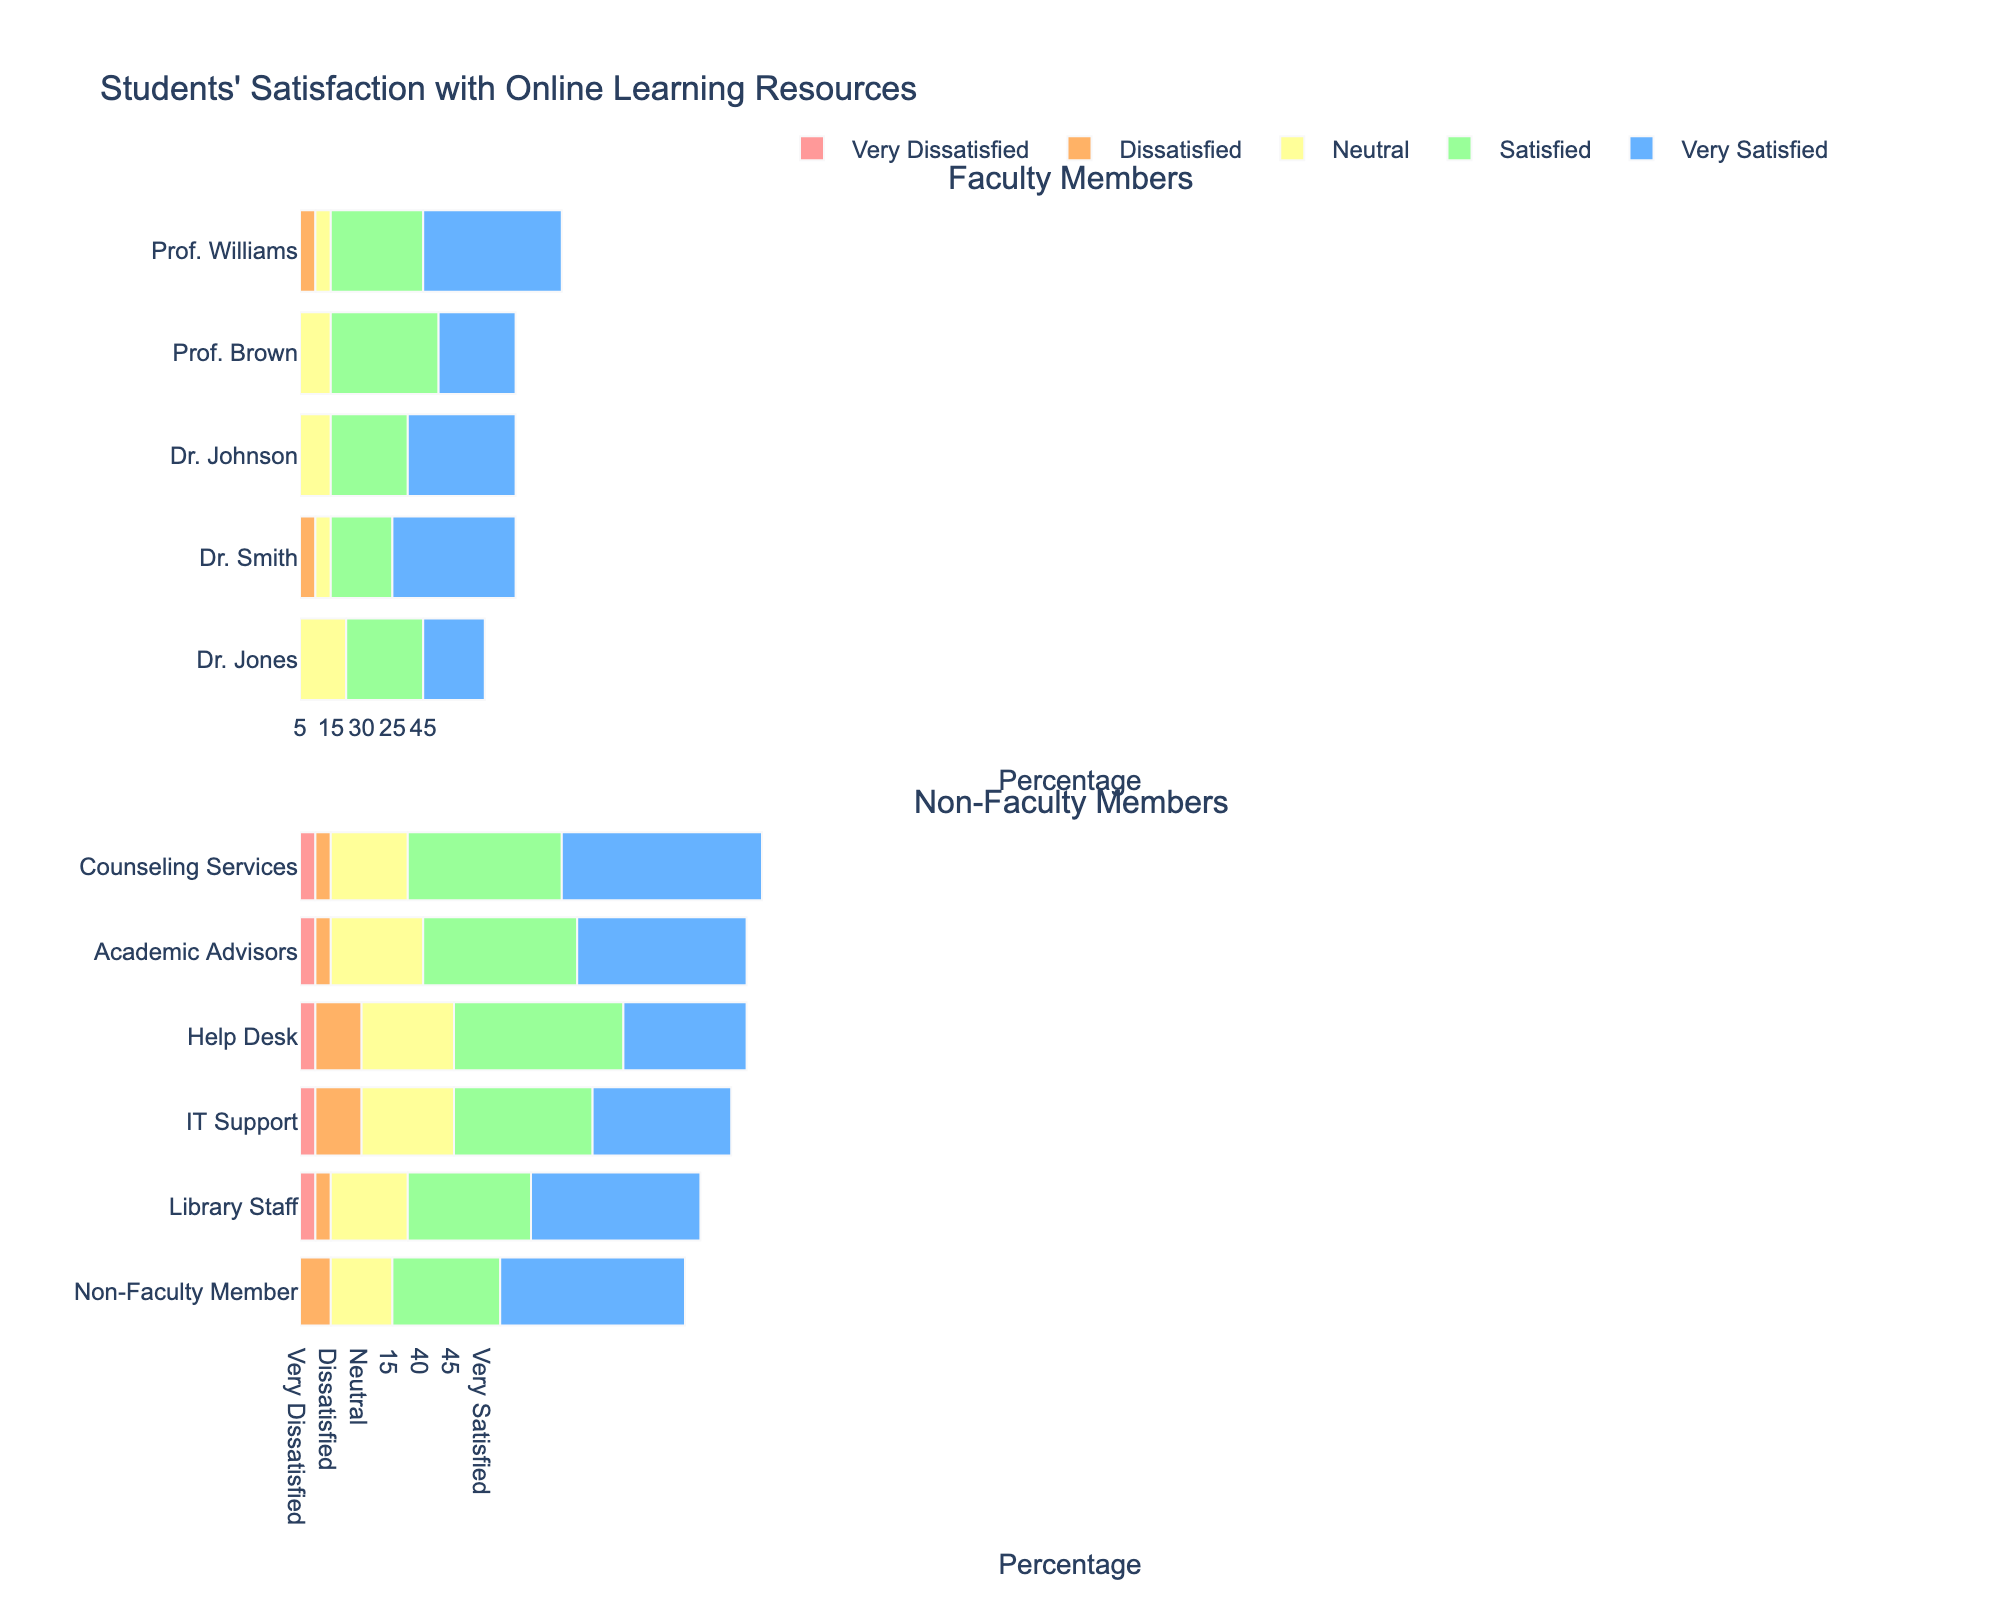What's the total number of students either satisfied or very satisfied with Dr. Smith's resources? First, find the number of students who are satisfied (30) and very satisfied (45) with Dr. Smith's resources. Then, sum these values: 30 + 45 = 75.
Answer: 75 Which non-faculty member has the highest neutral satisfaction rate? Compare the neutral satisfaction rates of all non-faculty members: Library Staff (20), IT Support (15), Counseling Services (20), Help Desk (15), and Academic Advisors (15). Both "Library Staff" and "Counseling Services" have the highest rate of 20.
Answer: Library Staff, Counseling Services Who has the lowest rate of very dissatisfied students among both faculty and non-faculty members? Compare the very dissatisfied rates across all entries: Dr. Smith (5), Dr. Johnson (5), Prof. Williams (5), Prof. Brown (5), Dr. Jones (5), Library Staff (5), IT Support (5), Counseling Services (5), Help Desk (5), and Academic Advisors (5). All have the lowest rate which is 5.
Answer: Multiple members (all 10 listed) Which category is represented by the color green, and what percentage does it represent for IT Support? In the plot's legend, green is used to represent "Satisfied." For IT Support, check the "Satisfied" category which is 35%.
Answer: Satisfied, 35% What is the difference in the number of very satisfied students between Dr. Smith and Academic Advisors? Dr. Smith has 45 very satisfied students and Academic Advisors have 30. The difference is 45 - 30 = 15.
Answer: 15 Who has the highest dissatisfaction rates (combining dissatisfied and very dissatisfied) among faculty members, and what is the percentage? For each faculty member, sum the dissatisfied and very dissatisfied rates: Dr. Smith (10 + 5 = 15), Dr. Johnson (5 + 5 = 10), Prof. Williams (10 + 5 = 15), Prof. Brown (5 + 5 = 10), Dr. Jones (5 + 5 = 10). Both Dr. Smith and Prof. Williams have the highest rate of 15%.
Answer: Dr. Smith, Prof. Williams, 15% Compare the percentage of Neutral feedback for Dr. Jones with that for Counseling Services. Which is higher and by how much? Dr. Jones has a neutral feedback of 20% and Counseling Services also has 20%. Thus, both have the same neutral feedback, so the difference is 0.
Answer: Same, 0 What is the overall percentage of students satisfied or very satisfied combined at the Help Desk? For the Help Desk, sum the percentages of satisfied (30%) and very satisfied (40%) students: 30 + 40 = 70%.
Answer: 70% 